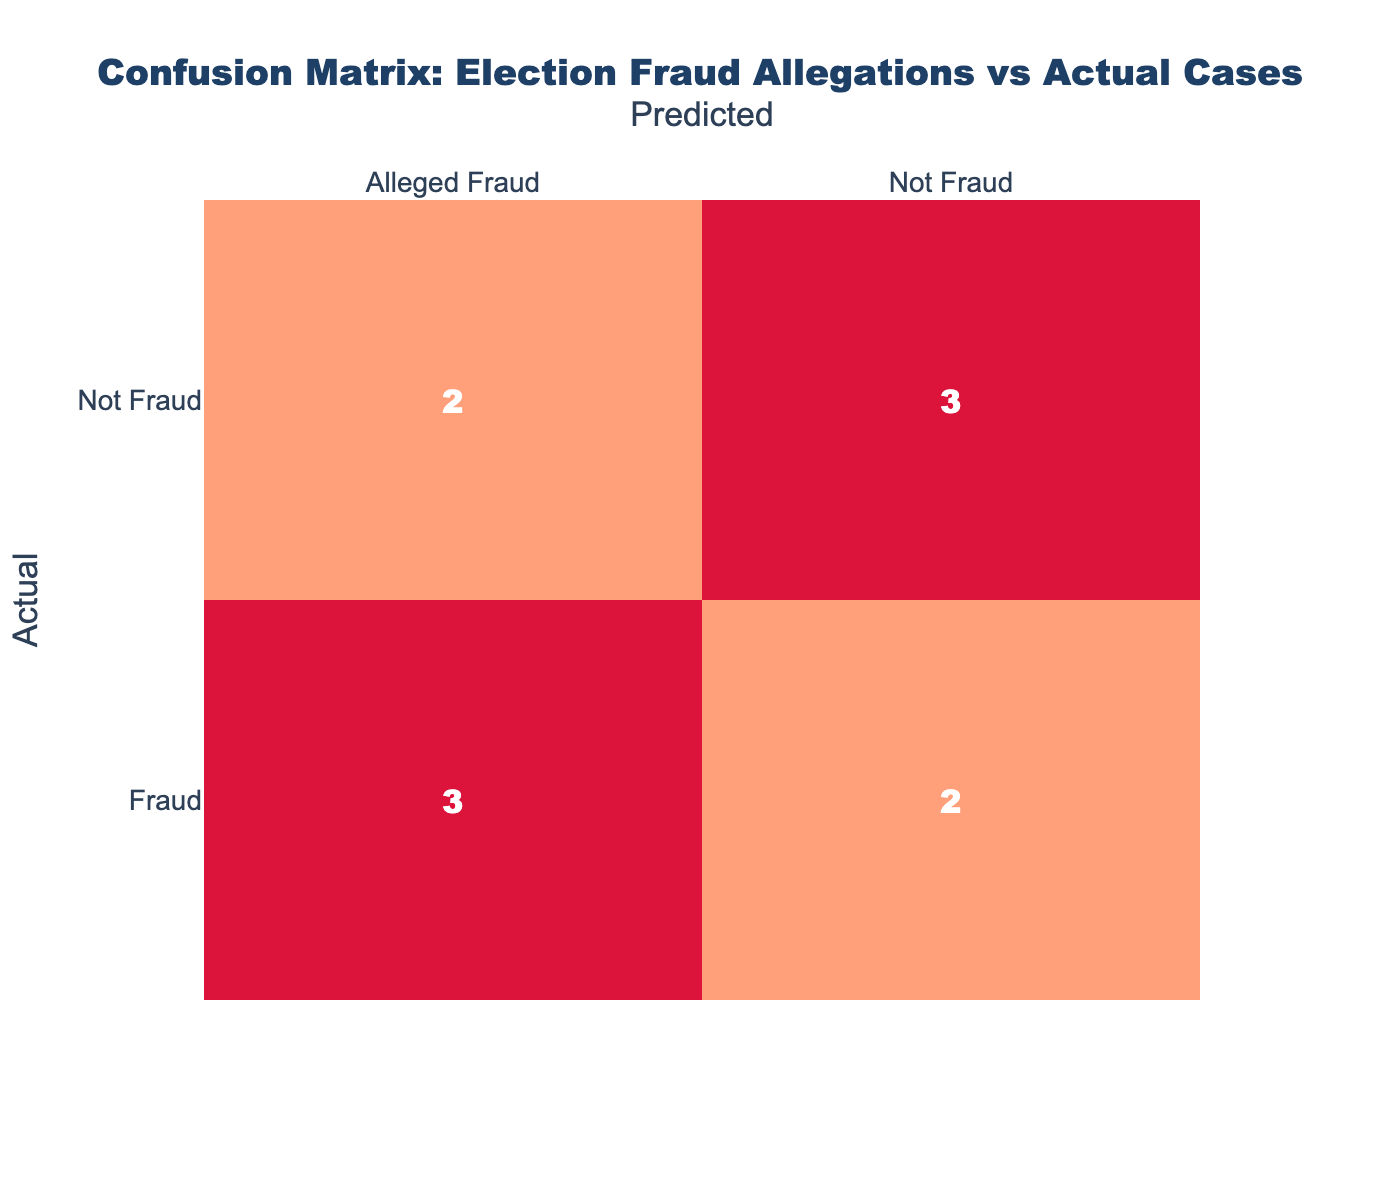What is the total number of actual fraud cases? In the confusion matrix, we can count the occurrences of "Fraud" in the "Actual" row. Looking at the table, there are 5 instances where "Fraud" is listed as the actual case.
Answer: 5 What is the total number of actual non-fraud cases? To find the total number of actual non-fraud cases, we look for the count of "Not Fraud" in the "Actual" row. There are 5 instances of "Not Fraud" listed.
Answer: 5 How many cases were predicted as "Not Fraud"? We assess the "Predicted" column and sum up all instances labeled as "Not Fraud". There are 5 cases predicted as "Not Fraud".
Answer: 5 What is the number of actual fraud cases that were predicted as "Not Fraud"? By evaluating the "Fraud" row under the "Not Fraud" column in the table, we see there is 1 case that was incorrectly predicted as "Not Fraud".
Answer: 1 How many actual cases were correctly classified as "Not Fraud"? We need to look for the "Not Fraud" under the "Not Fraud" predictions. In that cell, there are 4 cases correctly identified as "Not Fraud".
Answer: 4 Is there any actual fraud case that was predicted as "Alleged Fraud"? We can check the "Fraud" row under the "Alleged Fraud" column to confirm if there are fraud cases labeled as such. Indeed, there are 3 cases marked as "Alleged Fraud". Thus, the answer is yes.
Answer: Yes Are there more alleged fraud predictions than actual fraud cases? To determine this, we compare the total counts in the "Alleged Fraud" predictions (which total 5) to the actual fraud cases (which total 5). Since both numbers are equal, the statement is false.
Answer: No What percentage of predicted "Fraud" cases were actually fraudulent? Looking at the "Alleged Fraud" predictions for fraud cases, there are 3 true fraud cases among the 5 predicted. The calculation is (3/5)*100 = 60%. Thus, 60% of the predicted "Fraud" cases were actual frauds.
Answer: 60% If 2 out of the 5 "Alleged Fraud" predicted cases were actually true, what is the ratio of true claims to false claims? Out of 5 predictions labeled "Alleged Fraud", if 2 are true, then the remaining 3 must be false. The ratio of true claims (2) to false claims (3) is 2:3.
Answer: 2:3 